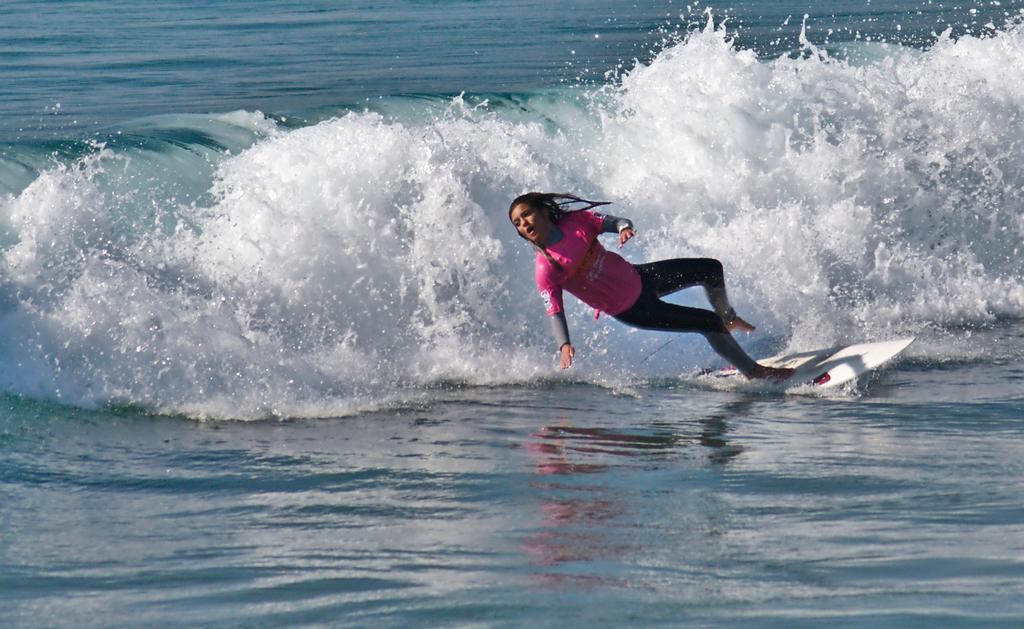Who is the main subject in the image? There is a girl in the image. What is the girl doing in the image? The girl is surfing in the water. What can be seen in the background of the image? There are waves in the background of the image. How many apples can be seen on the girl's surfboard in the image? There are no apples present in the image; the girl is surfing in the water. Is there a camp visible in the background of the image? There is no camp visible in the image; the background features waves. 